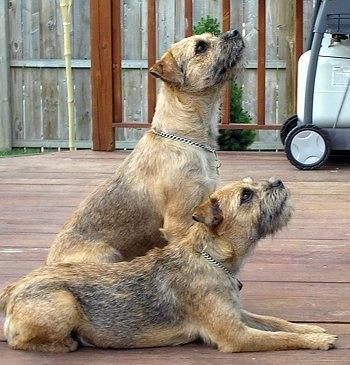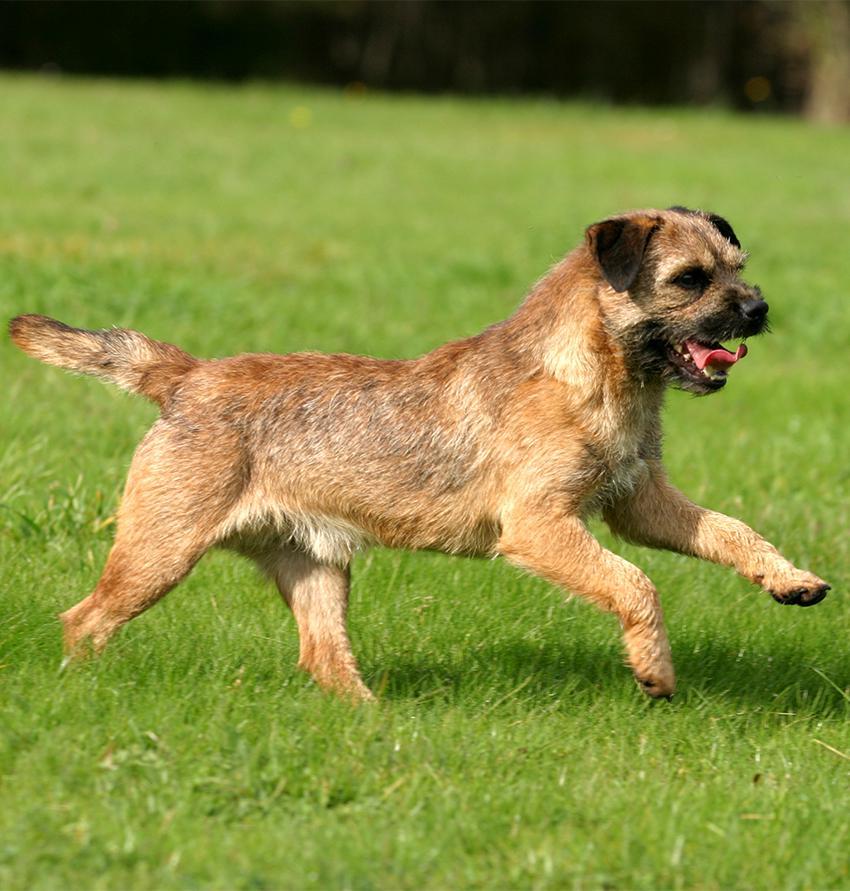The first image is the image on the left, the second image is the image on the right. Considering the images on both sides, is "One image includes a dog that is sitting upright, and the other image contains a single dog which is standing up." valid? Answer yes or no. Yes. The first image is the image on the left, the second image is the image on the right. Considering the images on both sides, is "The left and right image contains the same number of dogs with at least one in the grass." valid? Answer yes or no. No. 